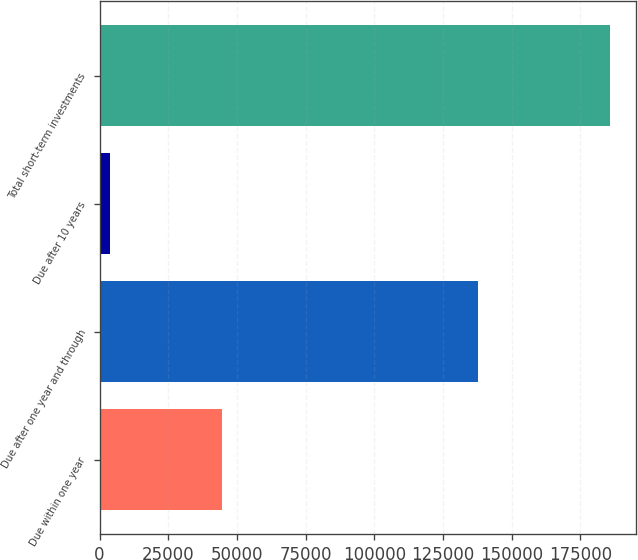Convert chart. <chart><loc_0><loc_0><loc_500><loc_500><bar_chart><fcel>Due within one year<fcel>Due after one year and through<fcel>Due after 10 years<fcel>Total short-term investments<nl><fcel>44455<fcel>137763<fcel>3800<fcel>186018<nl></chart> 